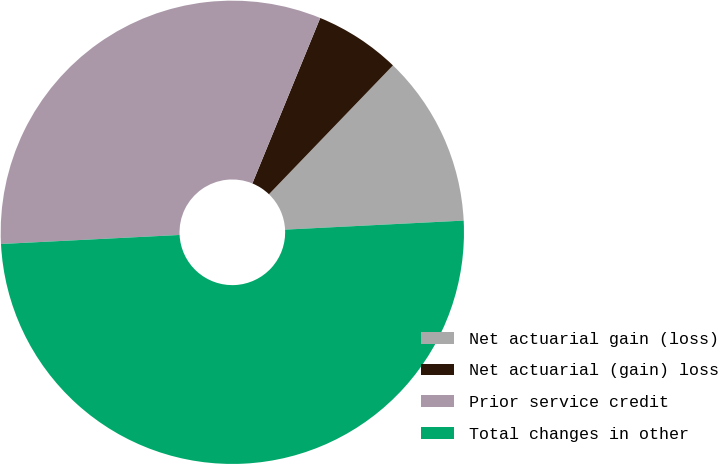<chart> <loc_0><loc_0><loc_500><loc_500><pie_chart><fcel>Net actuarial gain (loss)<fcel>Net actuarial (gain) loss<fcel>Prior service credit<fcel>Total changes in other<nl><fcel>12.0%<fcel>6.0%<fcel>32.0%<fcel>50.0%<nl></chart> 